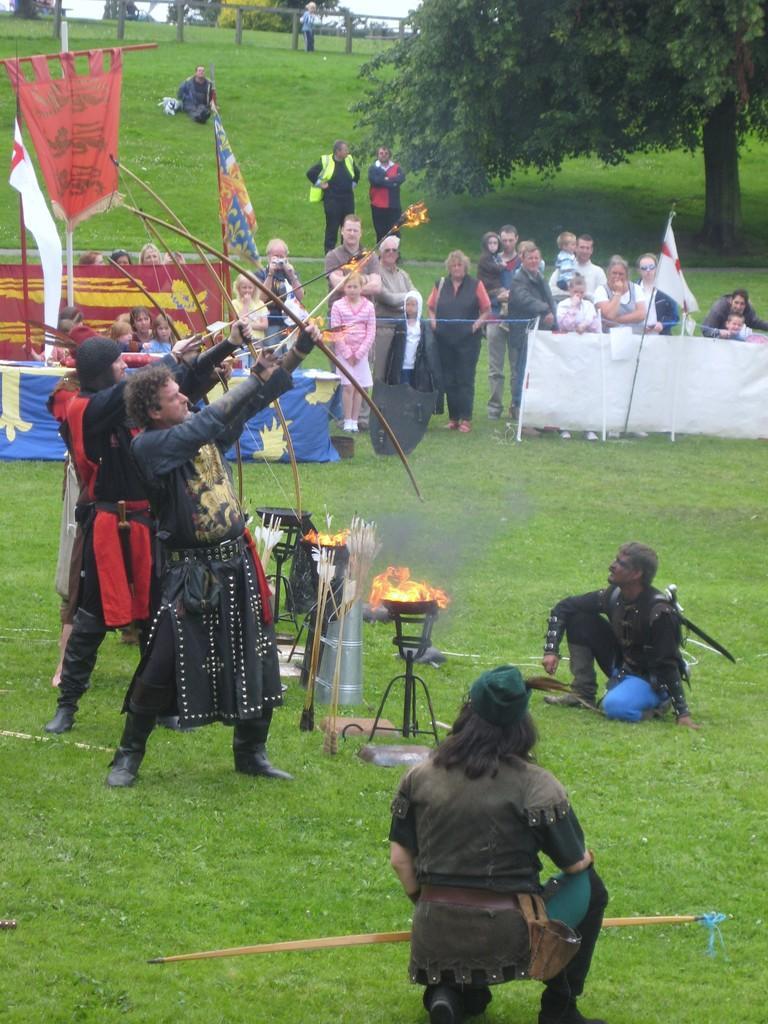In one or two sentences, can you explain what this image depicts? In this image I can see an open grass ground and on it I can see number of people. In the front I can see few people are wearing costumes and I can see few of them are holding bows and arrows. In the background I can see few flags, few clothes and number of trees. I can also see fire on these stands in the centre. 